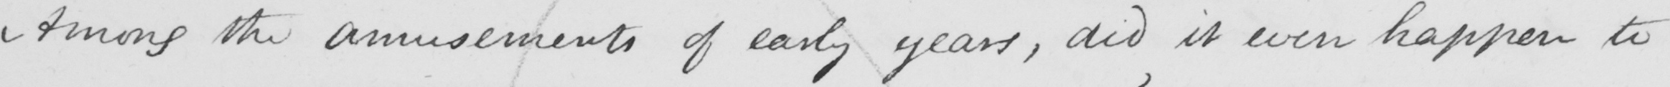What does this handwritten line say? Among the amusements of early years , did it ever happen to 